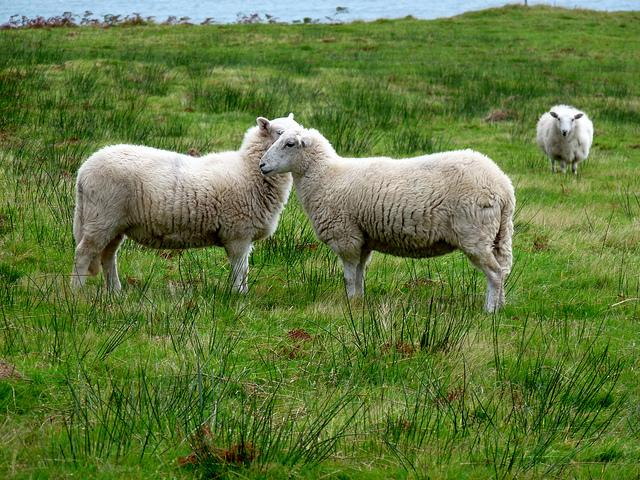How many sheep are standing around in the cape field?

Choices:
A) two
B) four
C) six
D) three three 